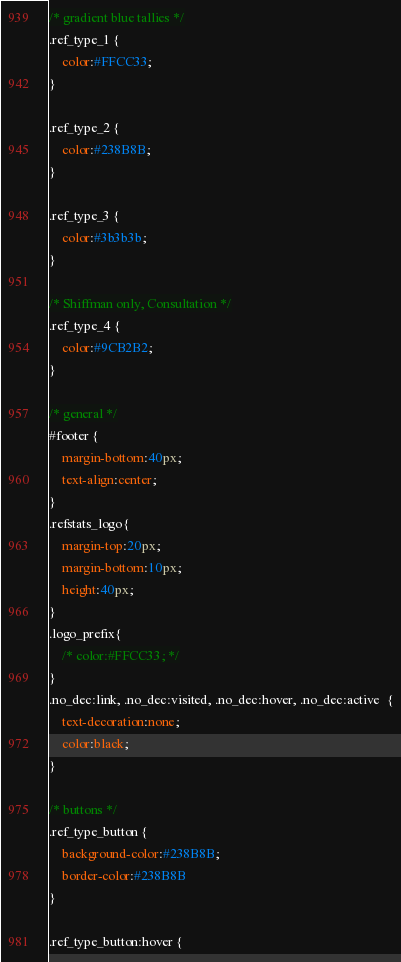<code> <loc_0><loc_0><loc_500><loc_500><_CSS_>/* gradient blue tallies */
.ref_type_1 {
	color:#FFCC33; 	
}

.ref_type_2 {
	color:#238B8B; 	
}

.ref_type_3 {
	color:#3b3b3b;	 
}

/* Shiffman only, Consultation */
.ref_type_4 {
	color:#9CB2B2;	 
}

/* general */
#footer {
	margin-bottom:40px;
	text-align:center;
}
.refstats_logo{	
	margin-top:20px;
	margin-bottom:10px;
	height:40px;
}
.logo_prefix{
	/* color:#FFCC33; */
}
.no_dec:link, .no_dec:visited, .no_dec:hover, .no_dec:active  {
	text-decoration:none;
	color:black;
}

/* buttons */
.ref_type_button {
	background-color:#238B8B;
	border-color:#238B8B
}

.ref_type_button:hover {</code> 